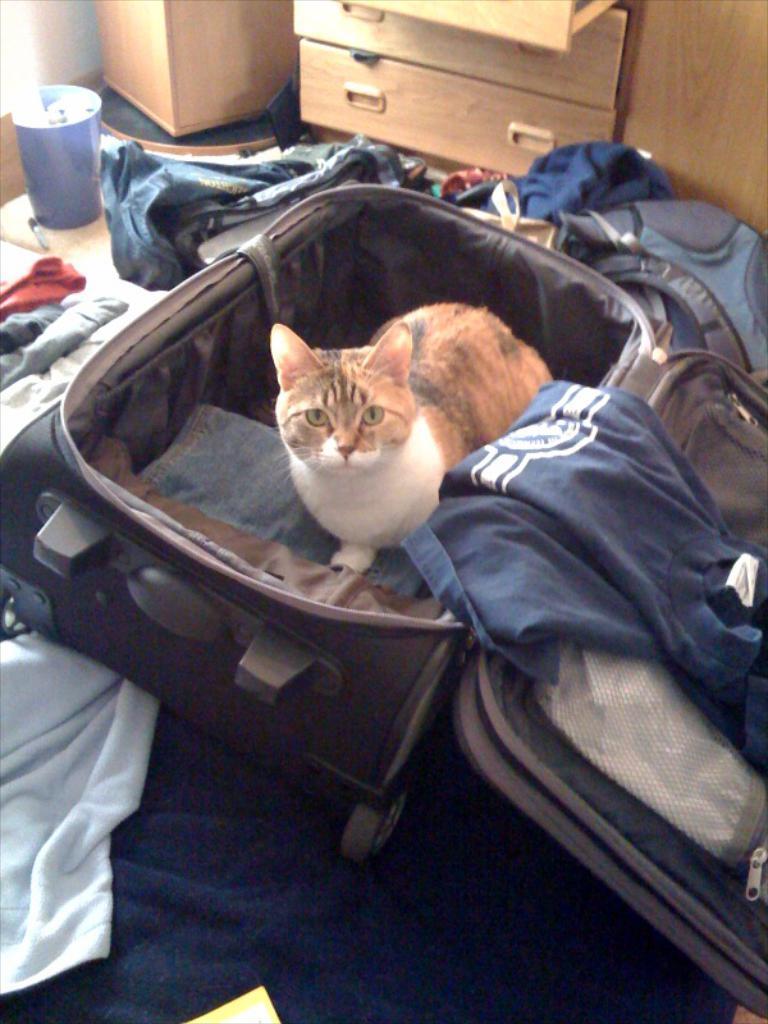Describe this image in one or two sentences. In this image I see a cat in a suitcase and there are clothes around the suitcase and I see a drawer over here. 